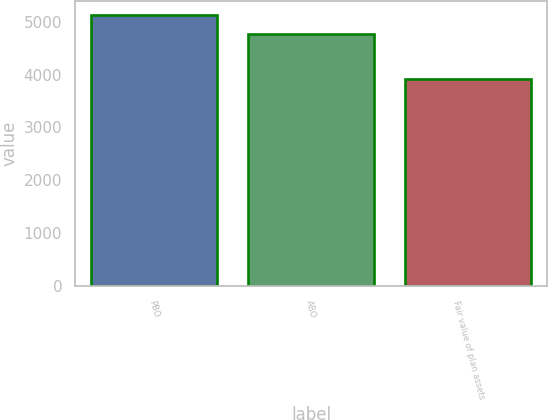Convert chart to OTSL. <chart><loc_0><loc_0><loc_500><loc_500><bar_chart><fcel>PBO<fcel>ABO<fcel>Fair value of plan assets<nl><fcel>5133<fcel>4774.4<fcel>3917<nl></chart> 